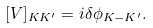<formula> <loc_0><loc_0><loc_500><loc_500>[ { V } ] _ { K K ^ { \prime } } = i \delta \phi _ { K - K ^ { \prime } } .</formula> 